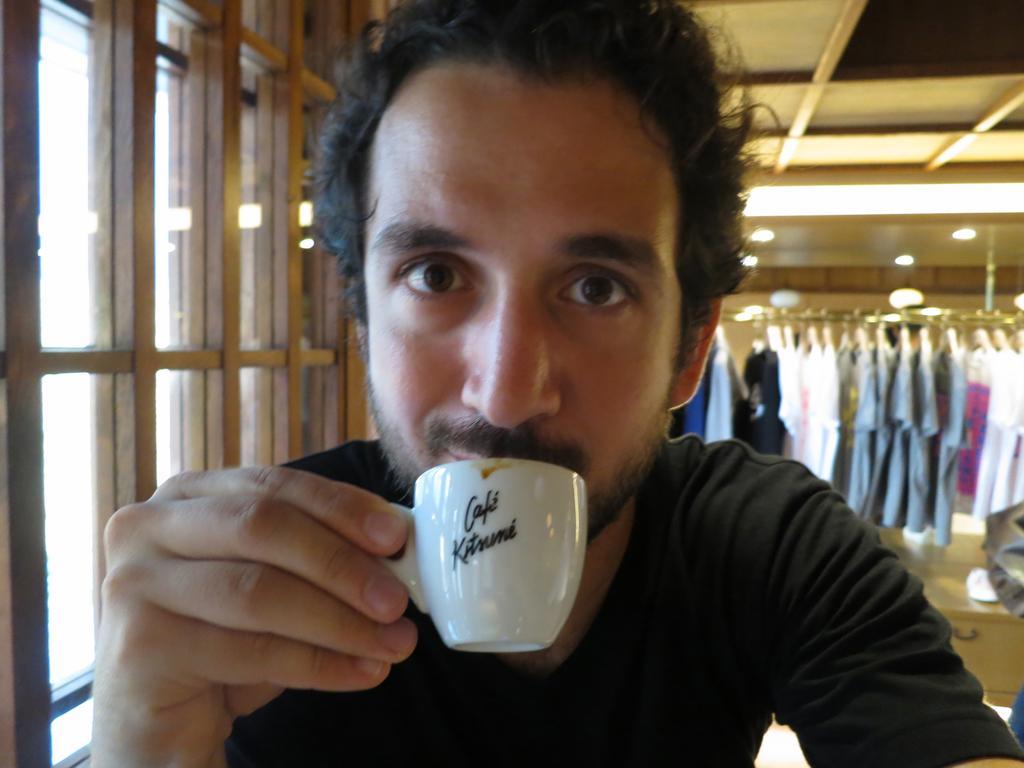Please provide a concise description of this image. In this picture there is a man sitting and sipping on cup of coffee and in the background there are some dresses and want to give left there is a window 